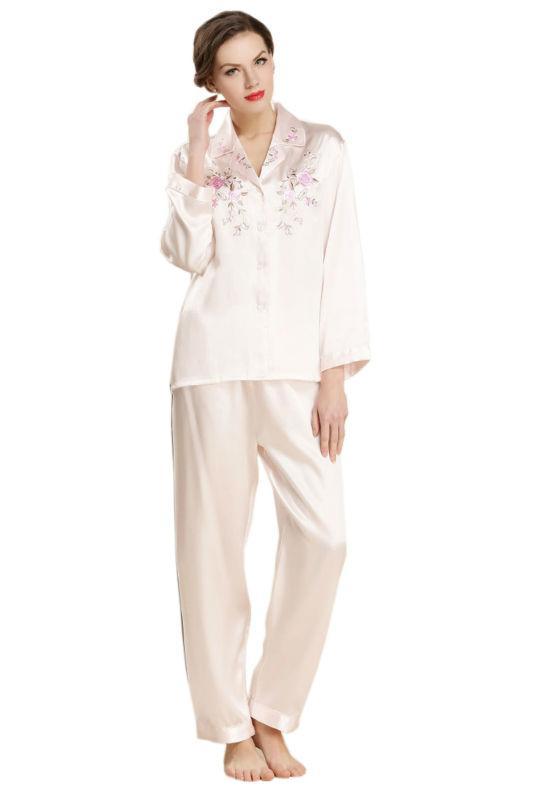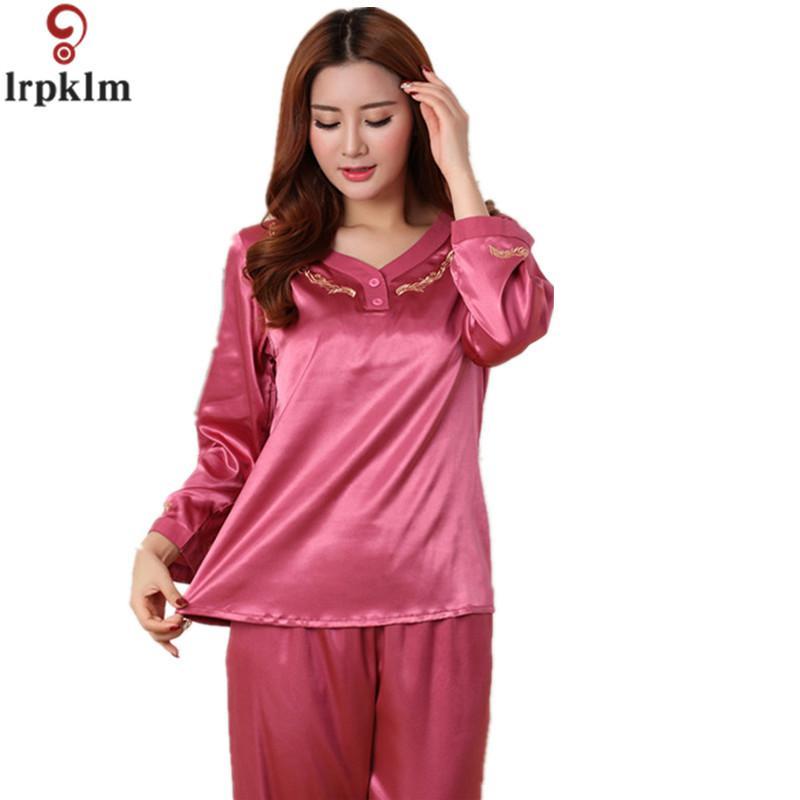The first image is the image on the left, the second image is the image on the right. Given the left and right images, does the statement "The left image shows a woman modeling matching pajama top and bottom." hold true? Answer yes or no. Yes. 